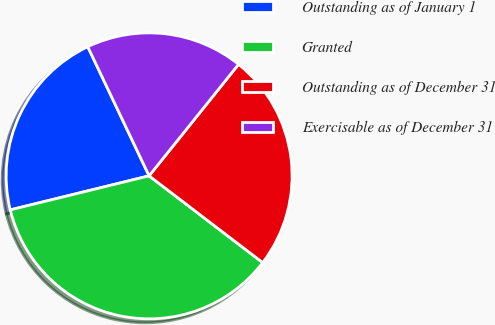Convert chart. <chart><loc_0><loc_0><loc_500><loc_500><pie_chart><fcel>Outstanding as of January 1<fcel>Granted<fcel>Outstanding as of December 31<fcel>Exercisable as of December 31<nl><fcel>21.77%<fcel>35.79%<fcel>24.62%<fcel>17.82%<nl></chart> 